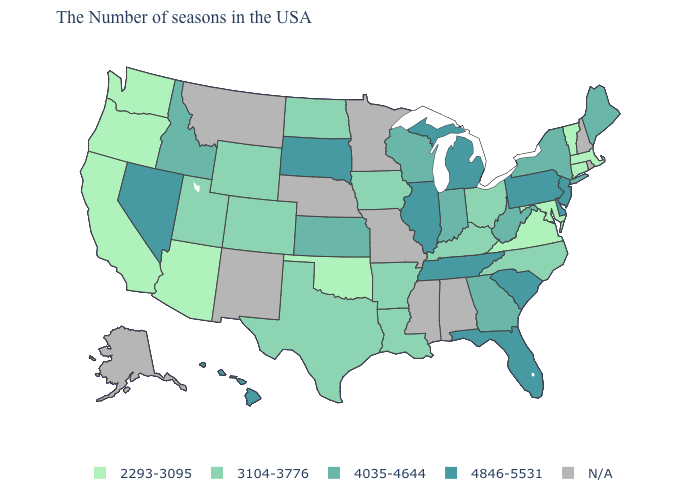Which states have the highest value in the USA?
Give a very brief answer. New Jersey, Delaware, Pennsylvania, South Carolina, Florida, Michigan, Tennessee, Illinois, South Dakota, Nevada, Hawaii. Among the states that border Nevada , does Arizona have the highest value?
Write a very short answer. No. What is the value of California?
Be succinct. 2293-3095. What is the value of Georgia?
Write a very short answer. 4035-4644. What is the value of Kentucky?
Give a very brief answer. 3104-3776. What is the lowest value in states that border Wisconsin?
Give a very brief answer. 3104-3776. Does Maine have the lowest value in the Northeast?
Keep it brief. No. What is the value of Ohio?
Short answer required. 3104-3776. Among the states that border Iowa , which have the lowest value?
Short answer required. Wisconsin. What is the value of Wisconsin?
Concise answer only. 4035-4644. Does New Jersey have the lowest value in the USA?
Give a very brief answer. No. Name the states that have a value in the range 4846-5531?
Write a very short answer. New Jersey, Delaware, Pennsylvania, South Carolina, Florida, Michigan, Tennessee, Illinois, South Dakota, Nevada, Hawaii. What is the highest value in the USA?
Keep it brief. 4846-5531. What is the lowest value in states that border Tennessee?
Quick response, please. 2293-3095. 